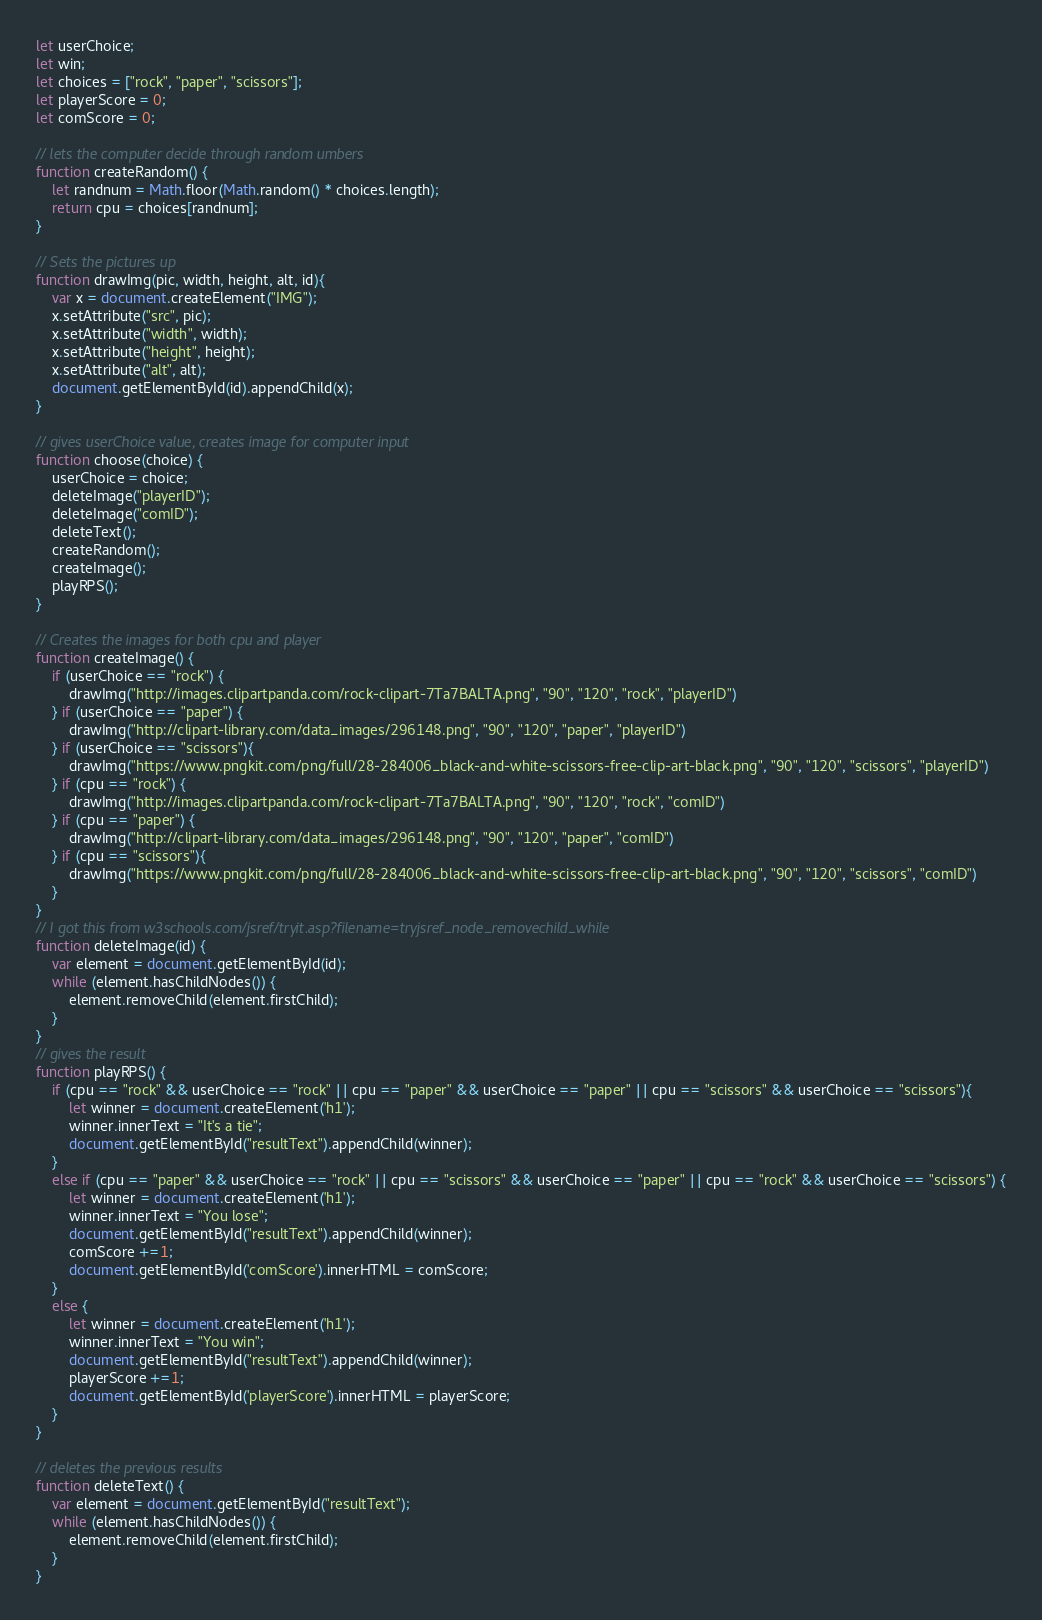<code> <loc_0><loc_0><loc_500><loc_500><_JavaScript_>let userChoice;
let win;
let choices = ["rock", "paper", "scissors"]; 
let playerScore = 0;
let comScore = 0;

// lets the computer decide through random umbers
function createRandom() {
    let randnum = Math.floor(Math.random() * choices.length);
    return cpu = choices[randnum];
}

// Sets the pictures up
function drawImg(pic, width, height, alt, id){
    var x = document.createElement("IMG");
    x.setAttribute("src", pic);
    x.setAttribute("width", width);
    x.setAttribute("height", height);
    x.setAttribute("alt", alt);
    document.getElementById(id).appendChild(x);
}

// gives userChoice value, creates image for computer input
function choose(choice) {
    userChoice = choice;
    deleteImage("playerID");
    deleteImage("comID");
    deleteText();
    createRandom();
    createImage();
    playRPS();
}

// Creates the images for both cpu and player
function createImage() {
    if (userChoice == "rock") {
        drawImg("http://images.clipartpanda.com/rock-clipart-7Ta7BALTA.png", "90", "120", "rock", "playerID")
    } if (userChoice == "paper") {
        drawImg("http://clipart-library.com/data_images/296148.png", "90", "120", "paper", "playerID")
    } if (userChoice == "scissors"){
        drawImg("https://www.pngkit.com/png/full/28-284006_black-and-white-scissors-free-clip-art-black.png", "90", "120", "scissors", "playerID")
    } if (cpu == "rock") {
        drawImg("http://images.clipartpanda.com/rock-clipart-7Ta7BALTA.png", "90", "120", "rock", "comID")
    } if (cpu == "paper") {
        drawImg("http://clipart-library.com/data_images/296148.png", "90", "120", "paper", "comID")
    } if (cpu == "scissors"){
        drawImg("https://www.pngkit.com/png/full/28-284006_black-and-white-scissors-free-clip-art-black.png", "90", "120", "scissors", "comID")
    } 
}
// I got this from w3schools.com/jsref/tryit.asp?filename=tryjsref_node_removechild_while 
function deleteImage(id) {
    var element = document.getElementById(id);
    while (element.hasChildNodes()) {
        element.removeChild(element.firstChild);
    }
}
// gives the result
function playRPS() {
    if (cpu == "rock" && userChoice == "rock" || cpu == "paper" && userChoice == "paper" || cpu == "scissors" && userChoice == "scissors"){
        let winner = document.createElement('h1');
        winner.innerText = "It's a tie";
        document.getElementById("resultText").appendChild(winner);
    }
    else if (cpu == "paper" && userChoice == "rock" || cpu == "scissors" && userChoice == "paper" || cpu == "rock" && userChoice == "scissors") {
        let winner = document.createElement('h1');
        winner.innerText = "You lose";
        document.getElementById("resultText").appendChild(winner);
        comScore +=1;
        document.getElementById('comScore').innerHTML = comScore;
    }
    else {
        let winner = document.createElement('h1');
        winner.innerText = "You win";
        document.getElementById("resultText").appendChild(winner);
        playerScore +=1;
        document.getElementById('playerScore').innerHTML = playerScore;
    }
}

// deletes the previous results
function deleteText() {
    var element = document.getElementById("resultText");
    while (element.hasChildNodes()) {
        element.removeChild(element.firstChild);
    }
}
</code> 